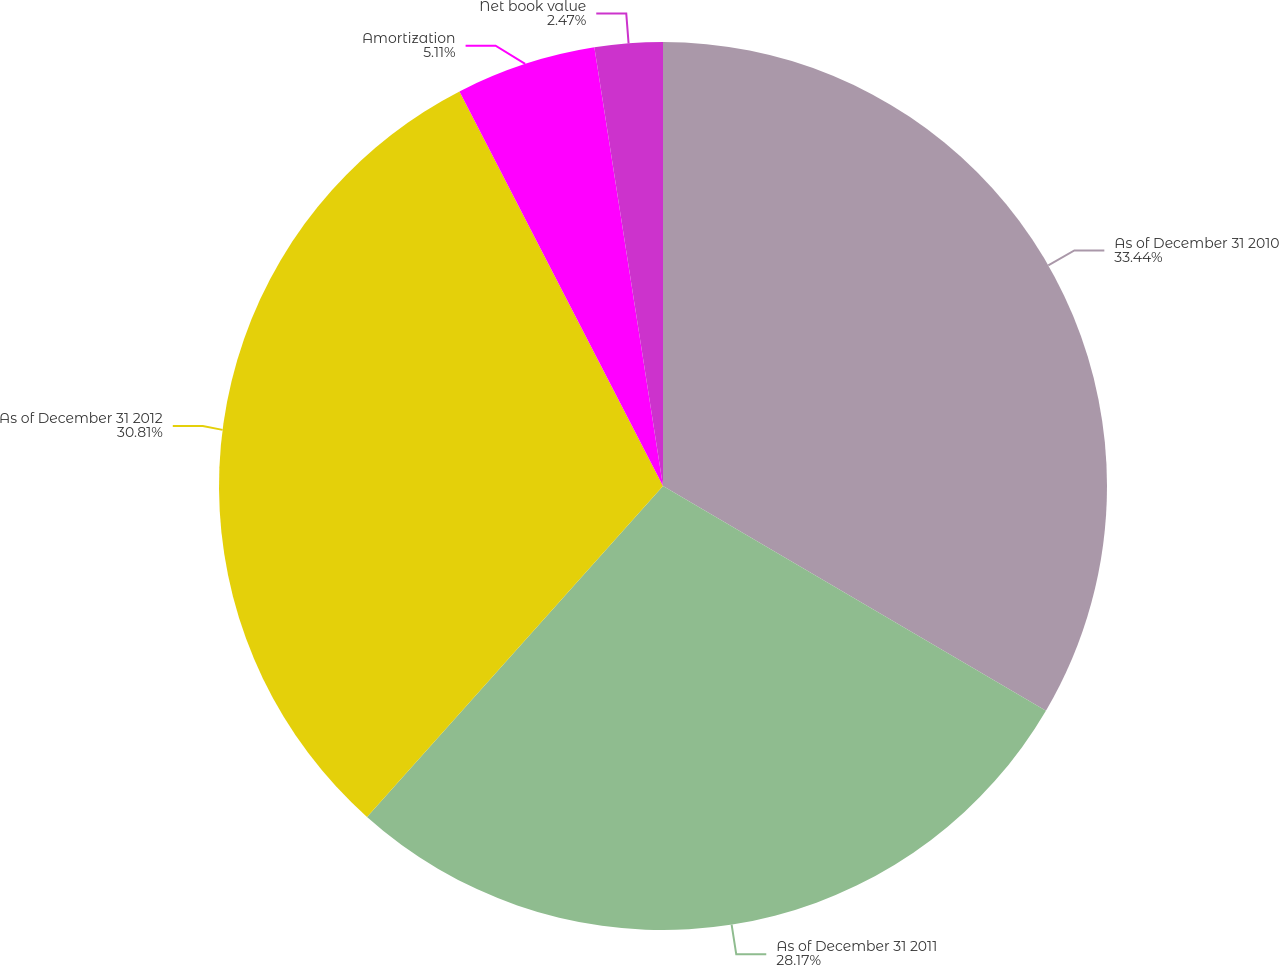Convert chart. <chart><loc_0><loc_0><loc_500><loc_500><pie_chart><fcel>As of December 31 2010<fcel>As of December 31 2011<fcel>As of December 31 2012<fcel>Amortization<fcel>Net book value<nl><fcel>33.45%<fcel>28.17%<fcel>30.81%<fcel>5.11%<fcel>2.47%<nl></chart> 